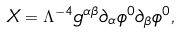Convert formula to latex. <formula><loc_0><loc_0><loc_500><loc_500>X = \Lambda ^ { - 4 } g ^ { \alpha \beta } \partial _ { \alpha } \phi ^ { 0 } \partial _ { \beta } \phi ^ { 0 } ,</formula> 